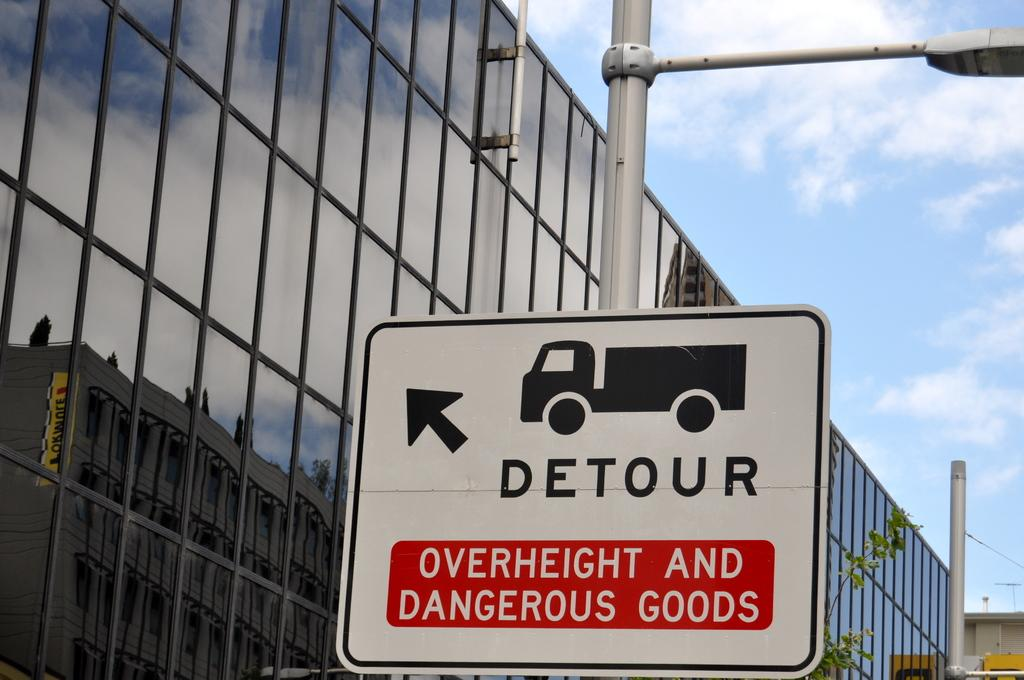Provide a one-sentence caption for the provided image. A detour sign with a picture of a truck warns of dangerous goods. 